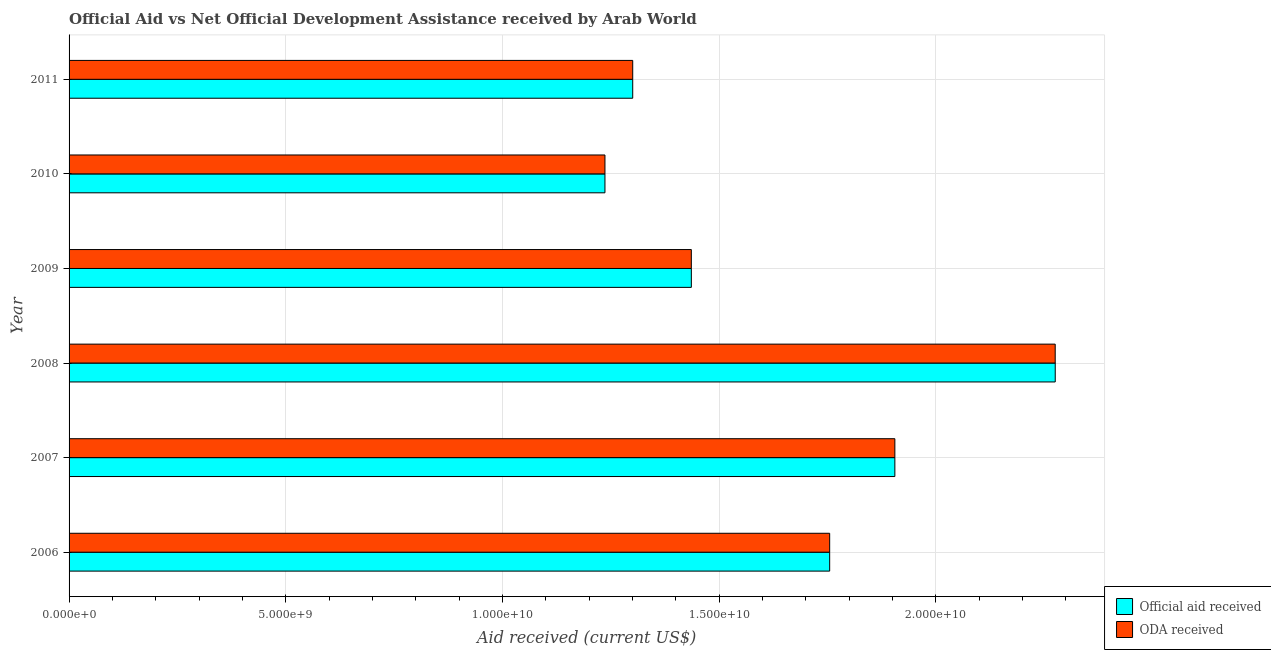How many bars are there on the 5th tick from the top?
Offer a terse response. 2. What is the label of the 3rd group of bars from the top?
Your response must be concise. 2009. In how many cases, is the number of bars for a given year not equal to the number of legend labels?
Provide a succinct answer. 0. What is the official aid received in 2011?
Keep it short and to the point. 1.30e+1. Across all years, what is the maximum oda received?
Offer a very short reply. 2.28e+1. Across all years, what is the minimum official aid received?
Your answer should be very brief. 1.24e+1. In which year was the oda received minimum?
Your answer should be compact. 2010. What is the total oda received in the graph?
Give a very brief answer. 9.91e+1. What is the difference between the oda received in 2006 and that in 2008?
Keep it short and to the point. -5.20e+09. What is the difference between the oda received in 2009 and the official aid received in 2007?
Provide a succinct answer. -4.70e+09. What is the average oda received per year?
Keep it short and to the point. 1.65e+1. In the year 2011, what is the difference between the oda received and official aid received?
Ensure brevity in your answer.  0. In how many years, is the official aid received greater than 2000000000 US$?
Give a very brief answer. 6. What is the ratio of the oda received in 2007 to that in 2011?
Offer a terse response. 1.47. Is the difference between the oda received in 2006 and 2011 greater than the difference between the official aid received in 2006 and 2011?
Offer a very short reply. No. What is the difference between the highest and the second highest oda received?
Give a very brief answer. 3.70e+09. What is the difference between the highest and the lowest official aid received?
Provide a succinct answer. 1.04e+1. In how many years, is the official aid received greater than the average official aid received taken over all years?
Your response must be concise. 3. What does the 1st bar from the top in 2011 represents?
Provide a succinct answer. ODA received. What does the 2nd bar from the bottom in 2011 represents?
Keep it short and to the point. ODA received. How many years are there in the graph?
Give a very brief answer. 6. Does the graph contain grids?
Your answer should be compact. Yes. Where does the legend appear in the graph?
Make the answer very short. Bottom right. How many legend labels are there?
Provide a short and direct response. 2. What is the title of the graph?
Offer a very short reply. Official Aid vs Net Official Development Assistance received by Arab World . Does "Diesel" appear as one of the legend labels in the graph?
Your answer should be very brief. No. What is the label or title of the X-axis?
Your answer should be very brief. Aid received (current US$). What is the label or title of the Y-axis?
Provide a succinct answer. Year. What is the Aid received (current US$) of Official aid received in 2006?
Provide a short and direct response. 1.76e+1. What is the Aid received (current US$) of ODA received in 2006?
Give a very brief answer. 1.76e+1. What is the Aid received (current US$) in Official aid received in 2007?
Give a very brief answer. 1.91e+1. What is the Aid received (current US$) of ODA received in 2007?
Ensure brevity in your answer.  1.91e+1. What is the Aid received (current US$) of Official aid received in 2008?
Keep it short and to the point. 2.28e+1. What is the Aid received (current US$) of ODA received in 2008?
Provide a succinct answer. 2.28e+1. What is the Aid received (current US$) of Official aid received in 2009?
Ensure brevity in your answer.  1.44e+1. What is the Aid received (current US$) in ODA received in 2009?
Provide a succinct answer. 1.44e+1. What is the Aid received (current US$) in Official aid received in 2010?
Your response must be concise. 1.24e+1. What is the Aid received (current US$) in ODA received in 2010?
Your answer should be very brief. 1.24e+1. What is the Aid received (current US$) of Official aid received in 2011?
Provide a short and direct response. 1.30e+1. What is the Aid received (current US$) in ODA received in 2011?
Offer a very short reply. 1.30e+1. Across all years, what is the maximum Aid received (current US$) of Official aid received?
Ensure brevity in your answer.  2.28e+1. Across all years, what is the maximum Aid received (current US$) of ODA received?
Keep it short and to the point. 2.28e+1. Across all years, what is the minimum Aid received (current US$) of Official aid received?
Make the answer very short. 1.24e+1. Across all years, what is the minimum Aid received (current US$) in ODA received?
Give a very brief answer. 1.24e+1. What is the total Aid received (current US$) in Official aid received in the graph?
Your answer should be very brief. 9.91e+1. What is the total Aid received (current US$) in ODA received in the graph?
Provide a short and direct response. 9.91e+1. What is the difference between the Aid received (current US$) of Official aid received in 2006 and that in 2007?
Provide a short and direct response. -1.50e+09. What is the difference between the Aid received (current US$) in ODA received in 2006 and that in 2007?
Your response must be concise. -1.50e+09. What is the difference between the Aid received (current US$) of Official aid received in 2006 and that in 2008?
Your response must be concise. -5.21e+09. What is the difference between the Aid received (current US$) of ODA received in 2006 and that in 2008?
Your answer should be compact. -5.20e+09. What is the difference between the Aid received (current US$) in Official aid received in 2006 and that in 2009?
Your answer should be compact. 3.19e+09. What is the difference between the Aid received (current US$) in ODA received in 2006 and that in 2009?
Offer a terse response. 3.19e+09. What is the difference between the Aid received (current US$) of Official aid received in 2006 and that in 2010?
Keep it short and to the point. 5.19e+09. What is the difference between the Aid received (current US$) of ODA received in 2006 and that in 2010?
Offer a terse response. 5.19e+09. What is the difference between the Aid received (current US$) in Official aid received in 2006 and that in 2011?
Ensure brevity in your answer.  4.55e+09. What is the difference between the Aid received (current US$) in ODA received in 2006 and that in 2011?
Offer a terse response. 4.55e+09. What is the difference between the Aid received (current US$) of Official aid received in 2007 and that in 2008?
Offer a very short reply. -3.70e+09. What is the difference between the Aid received (current US$) in ODA received in 2007 and that in 2008?
Your answer should be compact. -3.70e+09. What is the difference between the Aid received (current US$) of Official aid received in 2007 and that in 2009?
Ensure brevity in your answer.  4.70e+09. What is the difference between the Aid received (current US$) of ODA received in 2007 and that in 2009?
Offer a terse response. 4.70e+09. What is the difference between the Aid received (current US$) of Official aid received in 2007 and that in 2010?
Make the answer very short. 6.69e+09. What is the difference between the Aid received (current US$) of ODA received in 2007 and that in 2010?
Make the answer very short. 6.69e+09. What is the difference between the Aid received (current US$) of Official aid received in 2007 and that in 2011?
Provide a succinct answer. 6.05e+09. What is the difference between the Aid received (current US$) of ODA received in 2007 and that in 2011?
Give a very brief answer. 6.05e+09. What is the difference between the Aid received (current US$) of Official aid received in 2008 and that in 2009?
Keep it short and to the point. 8.40e+09. What is the difference between the Aid received (current US$) in ODA received in 2008 and that in 2009?
Your answer should be very brief. 8.40e+09. What is the difference between the Aid received (current US$) in Official aid received in 2008 and that in 2010?
Your answer should be compact. 1.04e+1. What is the difference between the Aid received (current US$) of ODA received in 2008 and that in 2010?
Your answer should be very brief. 1.04e+1. What is the difference between the Aid received (current US$) of Official aid received in 2008 and that in 2011?
Your answer should be very brief. 9.75e+09. What is the difference between the Aid received (current US$) of ODA received in 2008 and that in 2011?
Keep it short and to the point. 9.75e+09. What is the difference between the Aid received (current US$) of Official aid received in 2009 and that in 2010?
Offer a terse response. 1.99e+09. What is the difference between the Aid received (current US$) of ODA received in 2009 and that in 2010?
Give a very brief answer. 1.99e+09. What is the difference between the Aid received (current US$) in Official aid received in 2009 and that in 2011?
Give a very brief answer. 1.35e+09. What is the difference between the Aid received (current US$) of ODA received in 2009 and that in 2011?
Keep it short and to the point. 1.35e+09. What is the difference between the Aid received (current US$) of Official aid received in 2010 and that in 2011?
Make the answer very short. -6.41e+08. What is the difference between the Aid received (current US$) of ODA received in 2010 and that in 2011?
Provide a short and direct response. -6.41e+08. What is the difference between the Aid received (current US$) of Official aid received in 2006 and the Aid received (current US$) of ODA received in 2007?
Your response must be concise. -1.50e+09. What is the difference between the Aid received (current US$) of Official aid received in 2006 and the Aid received (current US$) of ODA received in 2008?
Make the answer very short. -5.20e+09. What is the difference between the Aid received (current US$) in Official aid received in 2006 and the Aid received (current US$) in ODA received in 2009?
Offer a very short reply. 3.19e+09. What is the difference between the Aid received (current US$) of Official aid received in 2006 and the Aid received (current US$) of ODA received in 2010?
Give a very brief answer. 5.19e+09. What is the difference between the Aid received (current US$) of Official aid received in 2006 and the Aid received (current US$) of ODA received in 2011?
Offer a terse response. 4.55e+09. What is the difference between the Aid received (current US$) of Official aid received in 2007 and the Aid received (current US$) of ODA received in 2008?
Make the answer very short. -3.70e+09. What is the difference between the Aid received (current US$) in Official aid received in 2007 and the Aid received (current US$) in ODA received in 2009?
Keep it short and to the point. 4.70e+09. What is the difference between the Aid received (current US$) in Official aid received in 2007 and the Aid received (current US$) in ODA received in 2010?
Provide a short and direct response. 6.69e+09. What is the difference between the Aid received (current US$) in Official aid received in 2007 and the Aid received (current US$) in ODA received in 2011?
Provide a succinct answer. 6.05e+09. What is the difference between the Aid received (current US$) in Official aid received in 2008 and the Aid received (current US$) in ODA received in 2009?
Give a very brief answer. 8.40e+09. What is the difference between the Aid received (current US$) of Official aid received in 2008 and the Aid received (current US$) of ODA received in 2010?
Provide a short and direct response. 1.04e+1. What is the difference between the Aid received (current US$) of Official aid received in 2008 and the Aid received (current US$) of ODA received in 2011?
Ensure brevity in your answer.  9.75e+09. What is the difference between the Aid received (current US$) in Official aid received in 2009 and the Aid received (current US$) in ODA received in 2010?
Make the answer very short. 1.99e+09. What is the difference between the Aid received (current US$) in Official aid received in 2009 and the Aid received (current US$) in ODA received in 2011?
Keep it short and to the point. 1.35e+09. What is the difference between the Aid received (current US$) in Official aid received in 2010 and the Aid received (current US$) in ODA received in 2011?
Offer a very short reply. -6.41e+08. What is the average Aid received (current US$) in Official aid received per year?
Your response must be concise. 1.65e+1. What is the average Aid received (current US$) in ODA received per year?
Your answer should be very brief. 1.65e+1. In the year 2007, what is the difference between the Aid received (current US$) in Official aid received and Aid received (current US$) in ODA received?
Offer a terse response. 0. In the year 2008, what is the difference between the Aid received (current US$) in Official aid received and Aid received (current US$) in ODA received?
Ensure brevity in your answer.  7.10e+05. In the year 2009, what is the difference between the Aid received (current US$) in Official aid received and Aid received (current US$) in ODA received?
Keep it short and to the point. 2.90e+05. What is the ratio of the Aid received (current US$) of Official aid received in 2006 to that in 2007?
Ensure brevity in your answer.  0.92. What is the ratio of the Aid received (current US$) in ODA received in 2006 to that in 2007?
Keep it short and to the point. 0.92. What is the ratio of the Aid received (current US$) in Official aid received in 2006 to that in 2008?
Offer a terse response. 0.77. What is the ratio of the Aid received (current US$) of ODA received in 2006 to that in 2008?
Keep it short and to the point. 0.77. What is the ratio of the Aid received (current US$) in Official aid received in 2006 to that in 2009?
Provide a succinct answer. 1.22. What is the ratio of the Aid received (current US$) of ODA received in 2006 to that in 2009?
Offer a very short reply. 1.22. What is the ratio of the Aid received (current US$) of Official aid received in 2006 to that in 2010?
Give a very brief answer. 1.42. What is the ratio of the Aid received (current US$) of ODA received in 2006 to that in 2010?
Give a very brief answer. 1.42. What is the ratio of the Aid received (current US$) of Official aid received in 2006 to that in 2011?
Provide a succinct answer. 1.35. What is the ratio of the Aid received (current US$) in ODA received in 2006 to that in 2011?
Offer a very short reply. 1.35. What is the ratio of the Aid received (current US$) of Official aid received in 2007 to that in 2008?
Ensure brevity in your answer.  0.84. What is the ratio of the Aid received (current US$) of ODA received in 2007 to that in 2008?
Your answer should be very brief. 0.84. What is the ratio of the Aid received (current US$) of Official aid received in 2007 to that in 2009?
Your answer should be compact. 1.33. What is the ratio of the Aid received (current US$) in ODA received in 2007 to that in 2009?
Your answer should be very brief. 1.33. What is the ratio of the Aid received (current US$) in Official aid received in 2007 to that in 2010?
Offer a very short reply. 1.54. What is the ratio of the Aid received (current US$) in ODA received in 2007 to that in 2010?
Make the answer very short. 1.54. What is the ratio of the Aid received (current US$) of Official aid received in 2007 to that in 2011?
Make the answer very short. 1.47. What is the ratio of the Aid received (current US$) in ODA received in 2007 to that in 2011?
Make the answer very short. 1.47. What is the ratio of the Aid received (current US$) of Official aid received in 2008 to that in 2009?
Offer a very short reply. 1.58. What is the ratio of the Aid received (current US$) in ODA received in 2008 to that in 2009?
Keep it short and to the point. 1.58. What is the ratio of the Aid received (current US$) of Official aid received in 2008 to that in 2010?
Offer a terse response. 1.84. What is the ratio of the Aid received (current US$) in ODA received in 2008 to that in 2010?
Offer a terse response. 1.84. What is the ratio of the Aid received (current US$) in Official aid received in 2008 to that in 2011?
Offer a terse response. 1.75. What is the ratio of the Aid received (current US$) of ODA received in 2008 to that in 2011?
Offer a very short reply. 1.75. What is the ratio of the Aid received (current US$) in Official aid received in 2009 to that in 2010?
Provide a short and direct response. 1.16. What is the ratio of the Aid received (current US$) in ODA received in 2009 to that in 2010?
Offer a very short reply. 1.16. What is the ratio of the Aid received (current US$) in Official aid received in 2009 to that in 2011?
Give a very brief answer. 1.1. What is the ratio of the Aid received (current US$) in ODA received in 2009 to that in 2011?
Give a very brief answer. 1.1. What is the ratio of the Aid received (current US$) in Official aid received in 2010 to that in 2011?
Offer a very short reply. 0.95. What is the ratio of the Aid received (current US$) of ODA received in 2010 to that in 2011?
Give a very brief answer. 0.95. What is the difference between the highest and the second highest Aid received (current US$) in Official aid received?
Offer a very short reply. 3.70e+09. What is the difference between the highest and the second highest Aid received (current US$) of ODA received?
Provide a short and direct response. 3.70e+09. What is the difference between the highest and the lowest Aid received (current US$) in Official aid received?
Your answer should be compact. 1.04e+1. What is the difference between the highest and the lowest Aid received (current US$) of ODA received?
Offer a terse response. 1.04e+1. 